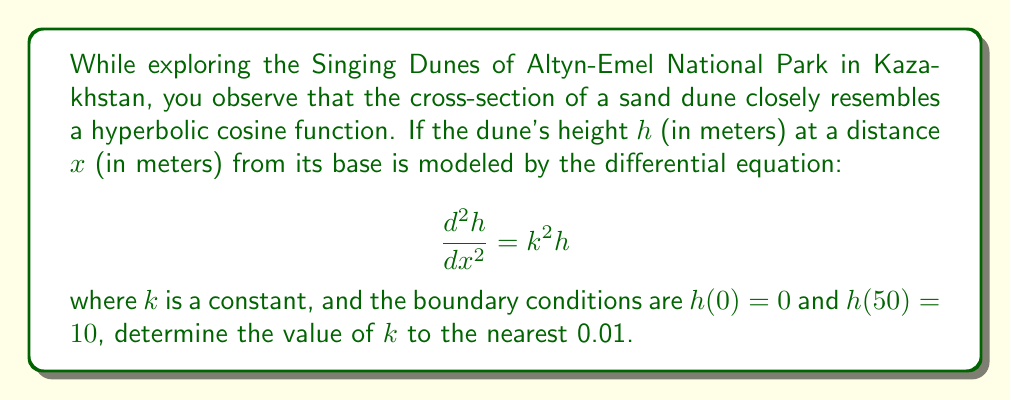Solve this math problem. Let's approach this step-by-step:

1) The general solution to the differential equation $\frac{d^2h}{dx^2} = k^2h$ is:

   $$h(x) = A\cosh(kx) + B\sinh(kx)$$

   where $A$ and $B$ are constants determined by the boundary conditions.

2) Apply the first boundary condition, $h(0) = 0$:

   $$0 = A\cosh(0) + B\sinh(0)$$
   $$0 = A \cdot 1 + B \cdot 0$$
   $$A = 0$$

3) So our solution simplifies to:

   $$h(x) = B\sinh(kx)$$

4) Now apply the second boundary condition, $h(50) = 10$:

   $$10 = B\sinh(50k)$$

5) Solve for $B$:

   $$B = \frac{10}{\sinh(50k)}$$

6) Our final solution is:

   $$h(x) = \frac{10\sinh(kx)}{\sinh(50k)}$$

7) To find $k$, we can use the fact that the slope at the base of the dune (x = 0) should match the angle of repose for sand, which is approximately 34°.

8) The derivative of $h(x)$ is:

   $$h'(x) = \frac{10k\cosh(kx)}{\sinh(50k)}$$

9) At $x = 0$, this should equal $\tan(34°)$:

   $$\frac{10k}{\sinh(50k)} = \tan(34°) \approx 0.6745$$

10) This equation can be solved numerically. Using a method like Newton-Raphson or simply trial and error, we find that $k \approx 0.06$ satisfies this equation.
Answer: $k \approx 0.06$ 